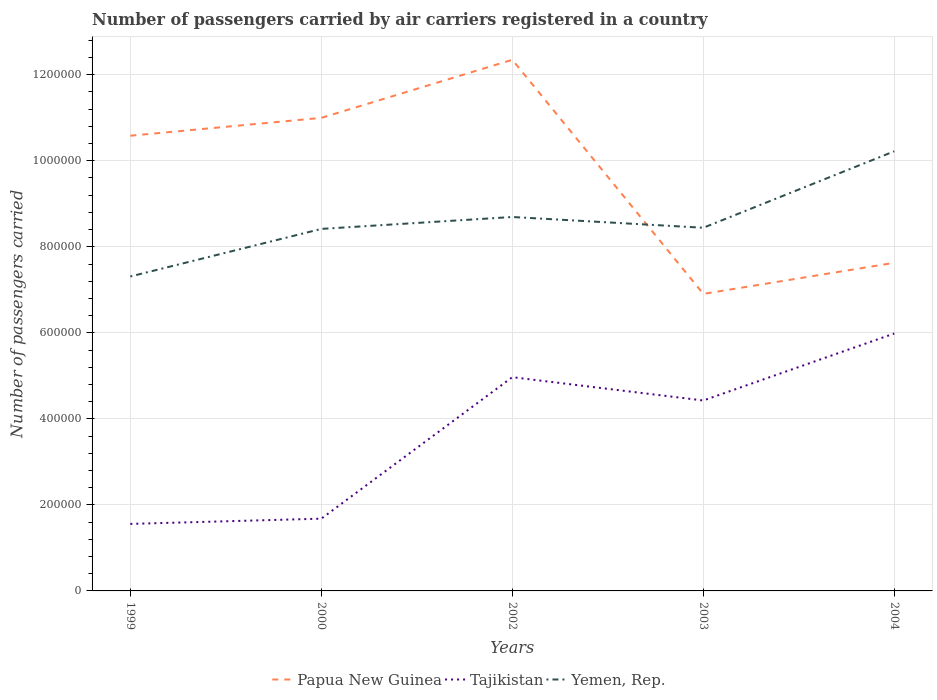Does the line corresponding to Yemen, Rep. intersect with the line corresponding to Papua New Guinea?
Offer a very short reply. Yes. Is the number of lines equal to the number of legend labels?
Ensure brevity in your answer.  Yes. Across all years, what is the maximum number of passengers carried by air carriers in Papua New Guinea?
Your answer should be compact. 6.91e+05. What is the total number of passengers carried by air carriers in Tajikistan in the graph?
Keep it short and to the point. -1.02e+05. What is the difference between the highest and the second highest number of passengers carried by air carriers in Papua New Guinea?
Your response must be concise. 5.44e+05. What is the difference between the highest and the lowest number of passengers carried by air carriers in Yemen, Rep.?
Offer a terse response. 2. How many lines are there?
Offer a very short reply. 3. How many years are there in the graph?
Offer a very short reply. 5. Are the values on the major ticks of Y-axis written in scientific E-notation?
Offer a terse response. No. Does the graph contain any zero values?
Provide a short and direct response. No. How many legend labels are there?
Make the answer very short. 3. How are the legend labels stacked?
Offer a very short reply. Horizontal. What is the title of the graph?
Offer a very short reply. Number of passengers carried by air carriers registered in a country. Does "Sint Maarten (Dutch part)" appear as one of the legend labels in the graph?
Offer a very short reply. No. What is the label or title of the Y-axis?
Ensure brevity in your answer.  Number of passengers carried. What is the Number of passengers carried in Papua New Guinea in 1999?
Provide a succinct answer. 1.06e+06. What is the Number of passengers carried of Tajikistan in 1999?
Your response must be concise. 1.56e+05. What is the Number of passengers carried of Yemen, Rep. in 1999?
Keep it short and to the point. 7.31e+05. What is the Number of passengers carried in Papua New Guinea in 2000?
Provide a succinct answer. 1.10e+06. What is the Number of passengers carried of Tajikistan in 2000?
Your response must be concise. 1.68e+05. What is the Number of passengers carried in Yemen, Rep. in 2000?
Keep it short and to the point. 8.42e+05. What is the Number of passengers carried in Papua New Guinea in 2002?
Give a very brief answer. 1.23e+06. What is the Number of passengers carried in Tajikistan in 2002?
Your answer should be very brief. 4.97e+05. What is the Number of passengers carried of Yemen, Rep. in 2002?
Provide a succinct answer. 8.69e+05. What is the Number of passengers carried of Papua New Guinea in 2003?
Ensure brevity in your answer.  6.91e+05. What is the Number of passengers carried in Tajikistan in 2003?
Offer a terse response. 4.43e+05. What is the Number of passengers carried in Yemen, Rep. in 2003?
Your answer should be compact. 8.44e+05. What is the Number of passengers carried of Papua New Guinea in 2004?
Offer a terse response. 7.63e+05. What is the Number of passengers carried of Tajikistan in 2004?
Provide a succinct answer. 5.98e+05. What is the Number of passengers carried in Yemen, Rep. in 2004?
Keep it short and to the point. 1.02e+06. Across all years, what is the maximum Number of passengers carried in Papua New Guinea?
Provide a succinct answer. 1.23e+06. Across all years, what is the maximum Number of passengers carried of Tajikistan?
Your answer should be very brief. 5.98e+05. Across all years, what is the maximum Number of passengers carried of Yemen, Rep.?
Provide a short and direct response. 1.02e+06. Across all years, what is the minimum Number of passengers carried of Papua New Guinea?
Offer a very short reply. 6.91e+05. Across all years, what is the minimum Number of passengers carried in Tajikistan?
Ensure brevity in your answer.  1.56e+05. Across all years, what is the minimum Number of passengers carried of Yemen, Rep.?
Offer a very short reply. 7.31e+05. What is the total Number of passengers carried of Papua New Guinea in the graph?
Ensure brevity in your answer.  4.85e+06. What is the total Number of passengers carried of Tajikistan in the graph?
Your answer should be very brief. 1.86e+06. What is the total Number of passengers carried of Yemen, Rep. in the graph?
Offer a very short reply. 4.31e+06. What is the difference between the Number of passengers carried in Papua New Guinea in 1999 and that in 2000?
Offer a very short reply. -4.16e+04. What is the difference between the Number of passengers carried in Tajikistan in 1999 and that in 2000?
Make the answer very short. -1.22e+04. What is the difference between the Number of passengers carried of Yemen, Rep. in 1999 and that in 2000?
Ensure brevity in your answer.  -1.11e+05. What is the difference between the Number of passengers carried in Papua New Guinea in 1999 and that in 2002?
Make the answer very short. -1.77e+05. What is the difference between the Number of passengers carried of Tajikistan in 1999 and that in 2002?
Your answer should be compact. -3.41e+05. What is the difference between the Number of passengers carried of Yemen, Rep. in 1999 and that in 2002?
Your answer should be compact. -1.38e+05. What is the difference between the Number of passengers carried of Papua New Guinea in 1999 and that in 2003?
Give a very brief answer. 3.68e+05. What is the difference between the Number of passengers carried of Tajikistan in 1999 and that in 2003?
Make the answer very short. -2.87e+05. What is the difference between the Number of passengers carried in Yemen, Rep. in 1999 and that in 2003?
Provide a short and direct response. -1.13e+05. What is the difference between the Number of passengers carried in Papua New Guinea in 1999 and that in 2004?
Ensure brevity in your answer.  2.95e+05. What is the difference between the Number of passengers carried of Tajikistan in 1999 and that in 2004?
Offer a very short reply. -4.43e+05. What is the difference between the Number of passengers carried in Yemen, Rep. in 1999 and that in 2004?
Make the answer very short. -2.91e+05. What is the difference between the Number of passengers carried of Papua New Guinea in 2000 and that in 2002?
Provide a short and direct response. -1.35e+05. What is the difference between the Number of passengers carried in Tajikistan in 2000 and that in 2002?
Your response must be concise. -3.29e+05. What is the difference between the Number of passengers carried in Yemen, Rep. in 2000 and that in 2002?
Provide a short and direct response. -2.77e+04. What is the difference between the Number of passengers carried of Papua New Guinea in 2000 and that in 2003?
Your answer should be very brief. 4.09e+05. What is the difference between the Number of passengers carried in Tajikistan in 2000 and that in 2003?
Provide a short and direct response. -2.75e+05. What is the difference between the Number of passengers carried of Yemen, Rep. in 2000 and that in 2003?
Keep it short and to the point. -2675. What is the difference between the Number of passengers carried in Papua New Guinea in 2000 and that in 2004?
Give a very brief answer. 3.37e+05. What is the difference between the Number of passengers carried in Tajikistan in 2000 and that in 2004?
Your response must be concise. -4.30e+05. What is the difference between the Number of passengers carried of Yemen, Rep. in 2000 and that in 2004?
Provide a succinct answer. -1.80e+05. What is the difference between the Number of passengers carried of Papua New Guinea in 2002 and that in 2003?
Your response must be concise. 5.44e+05. What is the difference between the Number of passengers carried of Tajikistan in 2002 and that in 2003?
Your response must be concise. 5.42e+04. What is the difference between the Number of passengers carried of Yemen, Rep. in 2002 and that in 2003?
Your response must be concise. 2.50e+04. What is the difference between the Number of passengers carried in Papua New Guinea in 2002 and that in 2004?
Keep it short and to the point. 4.72e+05. What is the difference between the Number of passengers carried of Tajikistan in 2002 and that in 2004?
Provide a succinct answer. -1.02e+05. What is the difference between the Number of passengers carried of Yemen, Rep. in 2002 and that in 2004?
Provide a short and direct response. -1.53e+05. What is the difference between the Number of passengers carried in Papua New Guinea in 2003 and that in 2004?
Your answer should be compact. -7.23e+04. What is the difference between the Number of passengers carried in Tajikistan in 2003 and that in 2004?
Provide a short and direct response. -1.56e+05. What is the difference between the Number of passengers carried in Yemen, Rep. in 2003 and that in 2004?
Your answer should be compact. -1.78e+05. What is the difference between the Number of passengers carried in Papua New Guinea in 1999 and the Number of passengers carried in Tajikistan in 2000?
Keep it short and to the point. 8.90e+05. What is the difference between the Number of passengers carried in Papua New Guinea in 1999 and the Number of passengers carried in Yemen, Rep. in 2000?
Keep it short and to the point. 2.17e+05. What is the difference between the Number of passengers carried in Tajikistan in 1999 and the Number of passengers carried in Yemen, Rep. in 2000?
Your answer should be compact. -6.86e+05. What is the difference between the Number of passengers carried of Papua New Guinea in 1999 and the Number of passengers carried of Tajikistan in 2002?
Provide a succinct answer. 5.61e+05. What is the difference between the Number of passengers carried in Papua New Guinea in 1999 and the Number of passengers carried in Yemen, Rep. in 2002?
Give a very brief answer. 1.89e+05. What is the difference between the Number of passengers carried of Tajikistan in 1999 and the Number of passengers carried of Yemen, Rep. in 2002?
Give a very brief answer. -7.13e+05. What is the difference between the Number of passengers carried in Papua New Guinea in 1999 and the Number of passengers carried in Tajikistan in 2003?
Your answer should be compact. 6.15e+05. What is the difference between the Number of passengers carried in Papua New Guinea in 1999 and the Number of passengers carried in Yemen, Rep. in 2003?
Ensure brevity in your answer.  2.14e+05. What is the difference between the Number of passengers carried of Tajikistan in 1999 and the Number of passengers carried of Yemen, Rep. in 2003?
Your answer should be compact. -6.88e+05. What is the difference between the Number of passengers carried in Papua New Guinea in 1999 and the Number of passengers carried in Tajikistan in 2004?
Your answer should be very brief. 4.60e+05. What is the difference between the Number of passengers carried of Papua New Guinea in 1999 and the Number of passengers carried of Yemen, Rep. in 2004?
Keep it short and to the point. 3.61e+04. What is the difference between the Number of passengers carried in Tajikistan in 1999 and the Number of passengers carried in Yemen, Rep. in 2004?
Your answer should be compact. -8.66e+05. What is the difference between the Number of passengers carried of Papua New Guinea in 2000 and the Number of passengers carried of Tajikistan in 2002?
Provide a short and direct response. 6.03e+05. What is the difference between the Number of passengers carried in Papua New Guinea in 2000 and the Number of passengers carried in Yemen, Rep. in 2002?
Your response must be concise. 2.30e+05. What is the difference between the Number of passengers carried of Tajikistan in 2000 and the Number of passengers carried of Yemen, Rep. in 2002?
Provide a short and direct response. -7.01e+05. What is the difference between the Number of passengers carried in Papua New Guinea in 2000 and the Number of passengers carried in Tajikistan in 2003?
Ensure brevity in your answer.  6.57e+05. What is the difference between the Number of passengers carried of Papua New Guinea in 2000 and the Number of passengers carried of Yemen, Rep. in 2003?
Your response must be concise. 2.55e+05. What is the difference between the Number of passengers carried of Tajikistan in 2000 and the Number of passengers carried of Yemen, Rep. in 2003?
Ensure brevity in your answer.  -6.76e+05. What is the difference between the Number of passengers carried in Papua New Guinea in 2000 and the Number of passengers carried in Tajikistan in 2004?
Keep it short and to the point. 5.01e+05. What is the difference between the Number of passengers carried in Papua New Guinea in 2000 and the Number of passengers carried in Yemen, Rep. in 2004?
Offer a very short reply. 7.77e+04. What is the difference between the Number of passengers carried in Tajikistan in 2000 and the Number of passengers carried in Yemen, Rep. in 2004?
Ensure brevity in your answer.  -8.54e+05. What is the difference between the Number of passengers carried of Papua New Guinea in 2002 and the Number of passengers carried of Tajikistan in 2003?
Ensure brevity in your answer.  7.92e+05. What is the difference between the Number of passengers carried in Papua New Guinea in 2002 and the Number of passengers carried in Yemen, Rep. in 2003?
Your answer should be very brief. 3.90e+05. What is the difference between the Number of passengers carried of Tajikistan in 2002 and the Number of passengers carried of Yemen, Rep. in 2003?
Your response must be concise. -3.47e+05. What is the difference between the Number of passengers carried in Papua New Guinea in 2002 and the Number of passengers carried in Tajikistan in 2004?
Provide a succinct answer. 6.36e+05. What is the difference between the Number of passengers carried in Papua New Guinea in 2002 and the Number of passengers carried in Yemen, Rep. in 2004?
Provide a short and direct response. 2.13e+05. What is the difference between the Number of passengers carried of Tajikistan in 2002 and the Number of passengers carried of Yemen, Rep. in 2004?
Offer a terse response. -5.25e+05. What is the difference between the Number of passengers carried in Papua New Guinea in 2003 and the Number of passengers carried in Tajikistan in 2004?
Offer a terse response. 9.21e+04. What is the difference between the Number of passengers carried of Papua New Guinea in 2003 and the Number of passengers carried of Yemen, Rep. in 2004?
Your answer should be very brief. -3.32e+05. What is the difference between the Number of passengers carried of Tajikistan in 2003 and the Number of passengers carried of Yemen, Rep. in 2004?
Give a very brief answer. -5.79e+05. What is the average Number of passengers carried in Papua New Guinea per year?
Offer a very short reply. 9.69e+05. What is the average Number of passengers carried in Tajikistan per year?
Provide a short and direct response. 3.72e+05. What is the average Number of passengers carried of Yemen, Rep. per year?
Your answer should be very brief. 8.62e+05. In the year 1999, what is the difference between the Number of passengers carried of Papua New Guinea and Number of passengers carried of Tajikistan?
Provide a short and direct response. 9.02e+05. In the year 1999, what is the difference between the Number of passengers carried in Papua New Guinea and Number of passengers carried in Yemen, Rep.?
Provide a short and direct response. 3.27e+05. In the year 1999, what is the difference between the Number of passengers carried in Tajikistan and Number of passengers carried in Yemen, Rep.?
Your response must be concise. -5.75e+05. In the year 2000, what is the difference between the Number of passengers carried of Papua New Guinea and Number of passengers carried of Tajikistan?
Offer a very short reply. 9.32e+05. In the year 2000, what is the difference between the Number of passengers carried in Papua New Guinea and Number of passengers carried in Yemen, Rep.?
Ensure brevity in your answer.  2.58e+05. In the year 2000, what is the difference between the Number of passengers carried of Tajikistan and Number of passengers carried of Yemen, Rep.?
Keep it short and to the point. -6.74e+05. In the year 2002, what is the difference between the Number of passengers carried of Papua New Guinea and Number of passengers carried of Tajikistan?
Make the answer very short. 7.38e+05. In the year 2002, what is the difference between the Number of passengers carried of Papua New Guinea and Number of passengers carried of Yemen, Rep.?
Make the answer very short. 3.65e+05. In the year 2002, what is the difference between the Number of passengers carried in Tajikistan and Number of passengers carried in Yemen, Rep.?
Your answer should be compact. -3.72e+05. In the year 2003, what is the difference between the Number of passengers carried of Papua New Guinea and Number of passengers carried of Tajikistan?
Ensure brevity in your answer.  2.48e+05. In the year 2003, what is the difference between the Number of passengers carried in Papua New Guinea and Number of passengers carried in Yemen, Rep.?
Offer a very short reply. -1.54e+05. In the year 2003, what is the difference between the Number of passengers carried of Tajikistan and Number of passengers carried of Yemen, Rep.?
Keep it short and to the point. -4.02e+05. In the year 2004, what is the difference between the Number of passengers carried in Papua New Guinea and Number of passengers carried in Tajikistan?
Your answer should be very brief. 1.64e+05. In the year 2004, what is the difference between the Number of passengers carried in Papua New Guinea and Number of passengers carried in Yemen, Rep.?
Offer a very short reply. -2.59e+05. In the year 2004, what is the difference between the Number of passengers carried in Tajikistan and Number of passengers carried in Yemen, Rep.?
Provide a succinct answer. -4.24e+05. What is the ratio of the Number of passengers carried in Papua New Guinea in 1999 to that in 2000?
Your answer should be compact. 0.96. What is the ratio of the Number of passengers carried of Tajikistan in 1999 to that in 2000?
Keep it short and to the point. 0.93. What is the ratio of the Number of passengers carried of Yemen, Rep. in 1999 to that in 2000?
Your answer should be compact. 0.87. What is the ratio of the Number of passengers carried of Papua New Guinea in 1999 to that in 2002?
Your response must be concise. 0.86. What is the ratio of the Number of passengers carried in Tajikistan in 1999 to that in 2002?
Offer a terse response. 0.31. What is the ratio of the Number of passengers carried in Yemen, Rep. in 1999 to that in 2002?
Keep it short and to the point. 0.84. What is the ratio of the Number of passengers carried in Papua New Guinea in 1999 to that in 2003?
Ensure brevity in your answer.  1.53. What is the ratio of the Number of passengers carried in Tajikistan in 1999 to that in 2003?
Provide a short and direct response. 0.35. What is the ratio of the Number of passengers carried of Yemen, Rep. in 1999 to that in 2003?
Your response must be concise. 0.87. What is the ratio of the Number of passengers carried in Papua New Guinea in 1999 to that in 2004?
Provide a short and direct response. 1.39. What is the ratio of the Number of passengers carried of Tajikistan in 1999 to that in 2004?
Offer a terse response. 0.26. What is the ratio of the Number of passengers carried of Yemen, Rep. in 1999 to that in 2004?
Provide a short and direct response. 0.72. What is the ratio of the Number of passengers carried of Papua New Guinea in 2000 to that in 2002?
Your answer should be very brief. 0.89. What is the ratio of the Number of passengers carried of Tajikistan in 2000 to that in 2002?
Offer a terse response. 0.34. What is the ratio of the Number of passengers carried in Yemen, Rep. in 2000 to that in 2002?
Your response must be concise. 0.97. What is the ratio of the Number of passengers carried in Papua New Guinea in 2000 to that in 2003?
Make the answer very short. 1.59. What is the ratio of the Number of passengers carried in Tajikistan in 2000 to that in 2003?
Give a very brief answer. 0.38. What is the ratio of the Number of passengers carried of Papua New Guinea in 2000 to that in 2004?
Ensure brevity in your answer.  1.44. What is the ratio of the Number of passengers carried in Tajikistan in 2000 to that in 2004?
Keep it short and to the point. 0.28. What is the ratio of the Number of passengers carried of Yemen, Rep. in 2000 to that in 2004?
Provide a succinct answer. 0.82. What is the ratio of the Number of passengers carried in Papua New Guinea in 2002 to that in 2003?
Your answer should be very brief. 1.79. What is the ratio of the Number of passengers carried of Tajikistan in 2002 to that in 2003?
Make the answer very short. 1.12. What is the ratio of the Number of passengers carried of Yemen, Rep. in 2002 to that in 2003?
Make the answer very short. 1.03. What is the ratio of the Number of passengers carried in Papua New Guinea in 2002 to that in 2004?
Offer a terse response. 1.62. What is the ratio of the Number of passengers carried in Tajikistan in 2002 to that in 2004?
Your response must be concise. 0.83. What is the ratio of the Number of passengers carried in Yemen, Rep. in 2002 to that in 2004?
Keep it short and to the point. 0.85. What is the ratio of the Number of passengers carried of Papua New Guinea in 2003 to that in 2004?
Keep it short and to the point. 0.91. What is the ratio of the Number of passengers carried of Tajikistan in 2003 to that in 2004?
Make the answer very short. 0.74. What is the ratio of the Number of passengers carried in Yemen, Rep. in 2003 to that in 2004?
Your answer should be very brief. 0.83. What is the difference between the highest and the second highest Number of passengers carried of Papua New Guinea?
Provide a succinct answer. 1.35e+05. What is the difference between the highest and the second highest Number of passengers carried of Tajikistan?
Make the answer very short. 1.02e+05. What is the difference between the highest and the second highest Number of passengers carried of Yemen, Rep.?
Offer a very short reply. 1.53e+05. What is the difference between the highest and the lowest Number of passengers carried in Papua New Guinea?
Your answer should be compact. 5.44e+05. What is the difference between the highest and the lowest Number of passengers carried of Tajikistan?
Your answer should be very brief. 4.43e+05. What is the difference between the highest and the lowest Number of passengers carried in Yemen, Rep.?
Your answer should be very brief. 2.91e+05. 